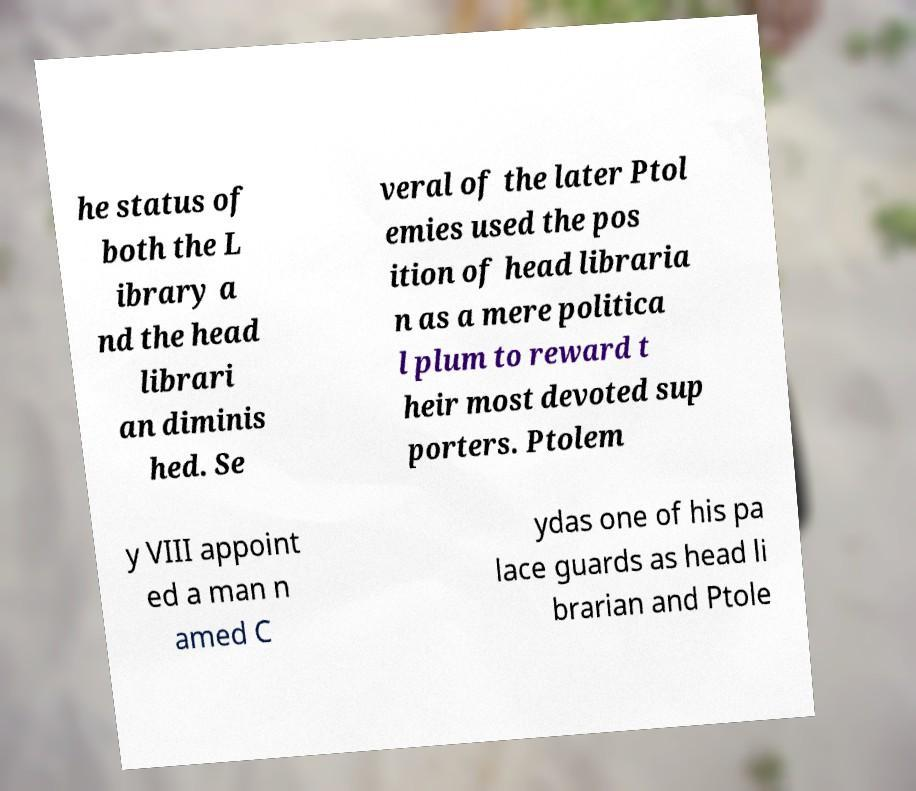There's text embedded in this image that I need extracted. Can you transcribe it verbatim? he status of both the L ibrary a nd the head librari an diminis hed. Se veral of the later Ptol emies used the pos ition of head libraria n as a mere politica l plum to reward t heir most devoted sup porters. Ptolem y VIII appoint ed a man n amed C ydas one of his pa lace guards as head li brarian and Ptole 